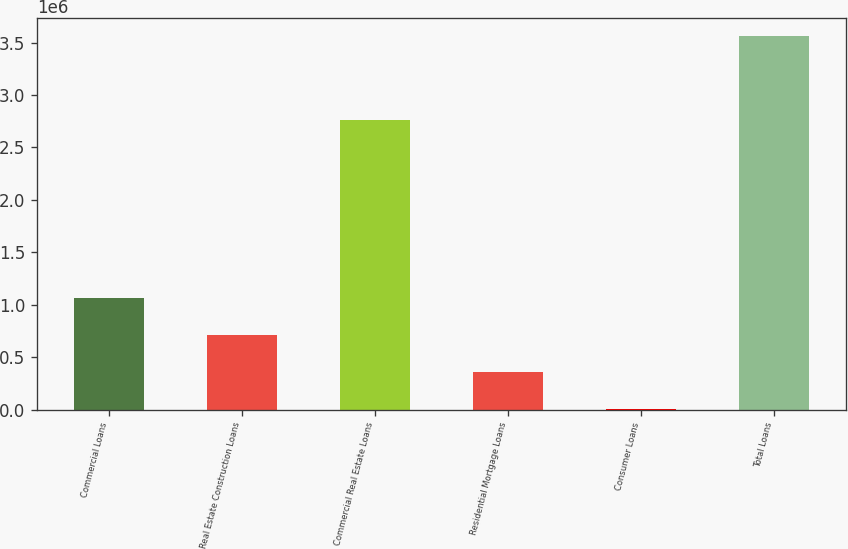Convert chart to OTSL. <chart><loc_0><loc_0><loc_500><loc_500><bar_chart><fcel>Commercial Loans<fcel>Real Estate Construction Loans<fcel>Commercial Real Estate Loans<fcel>Residential Mortgage Loans<fcel>Consumer Loans<fcel>Total Loans<nl><fcel>1.06808e+06<fcel>712236<fcel>2.7608e+06<fcel>356392<fcel>547<fcel>3.55899e+06<nl></chart> 